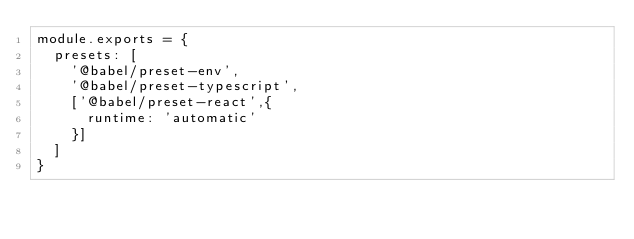<code> <loc_0><loc_0><loc_500><loc_500><_JavaScript_>module.exports = {
  presets: [
    '@babel/preset-env',
    '@babel/preset-typescript',
    ['@babel/preset-react',{
      runtime: 'automatic'
    }]
  ]
}</code> 